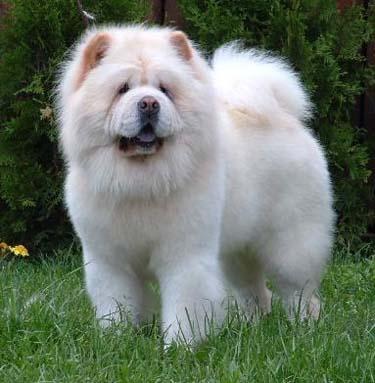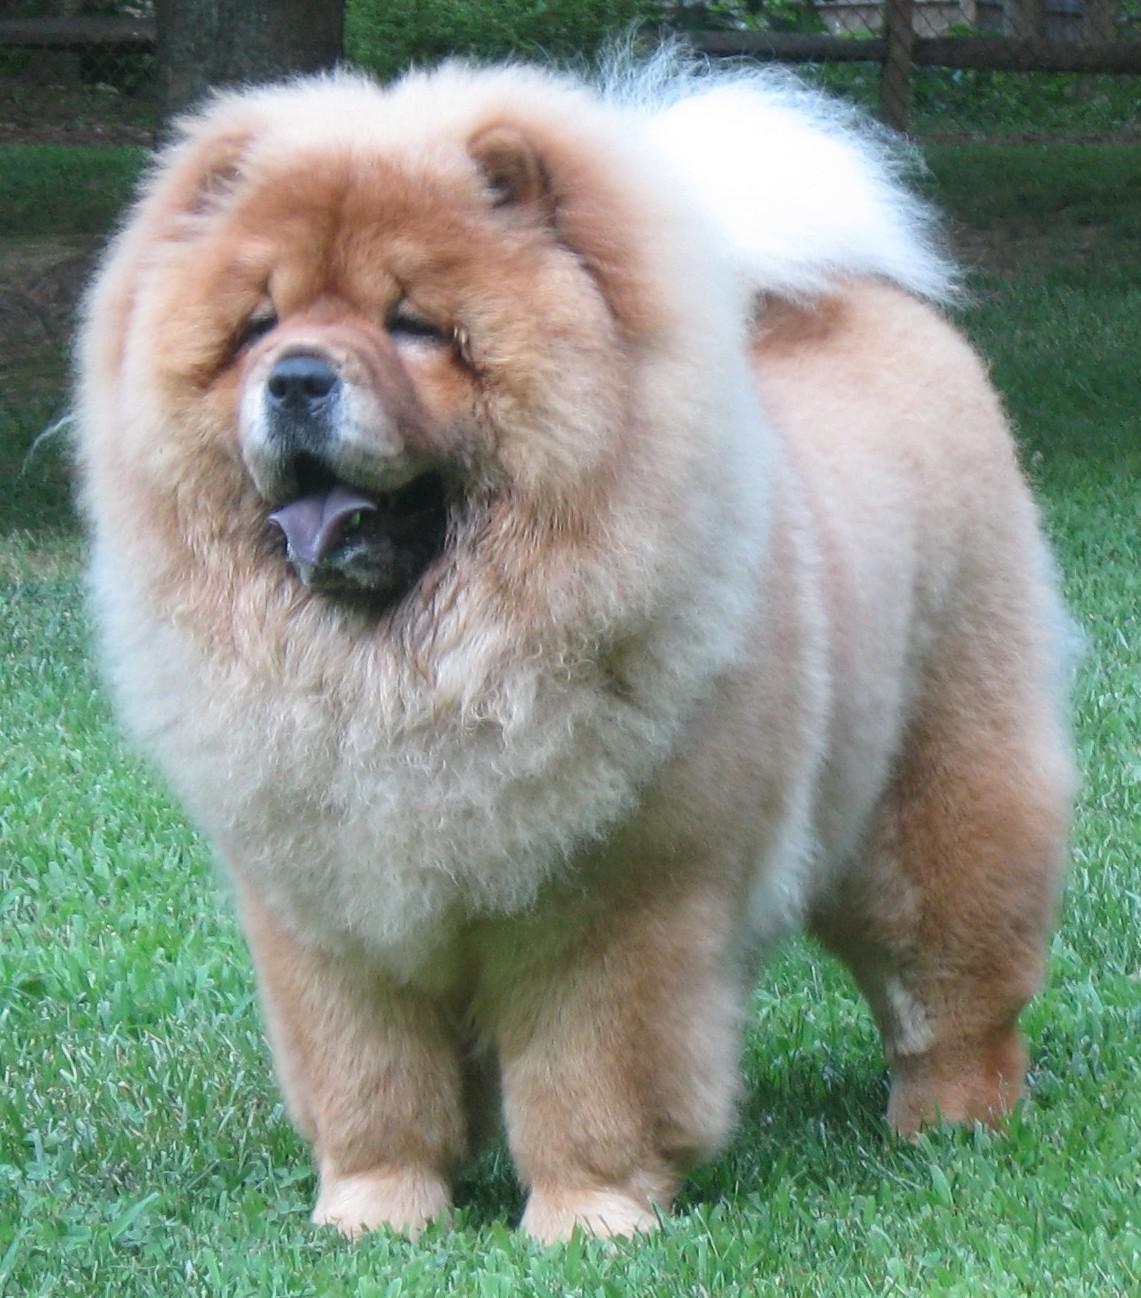The first image is the image on the left, the second image is the image on the right. Assess this claim about the two images: "Two dogs are standing on the grass". Correct or not? Answer yes or no. Yes. 